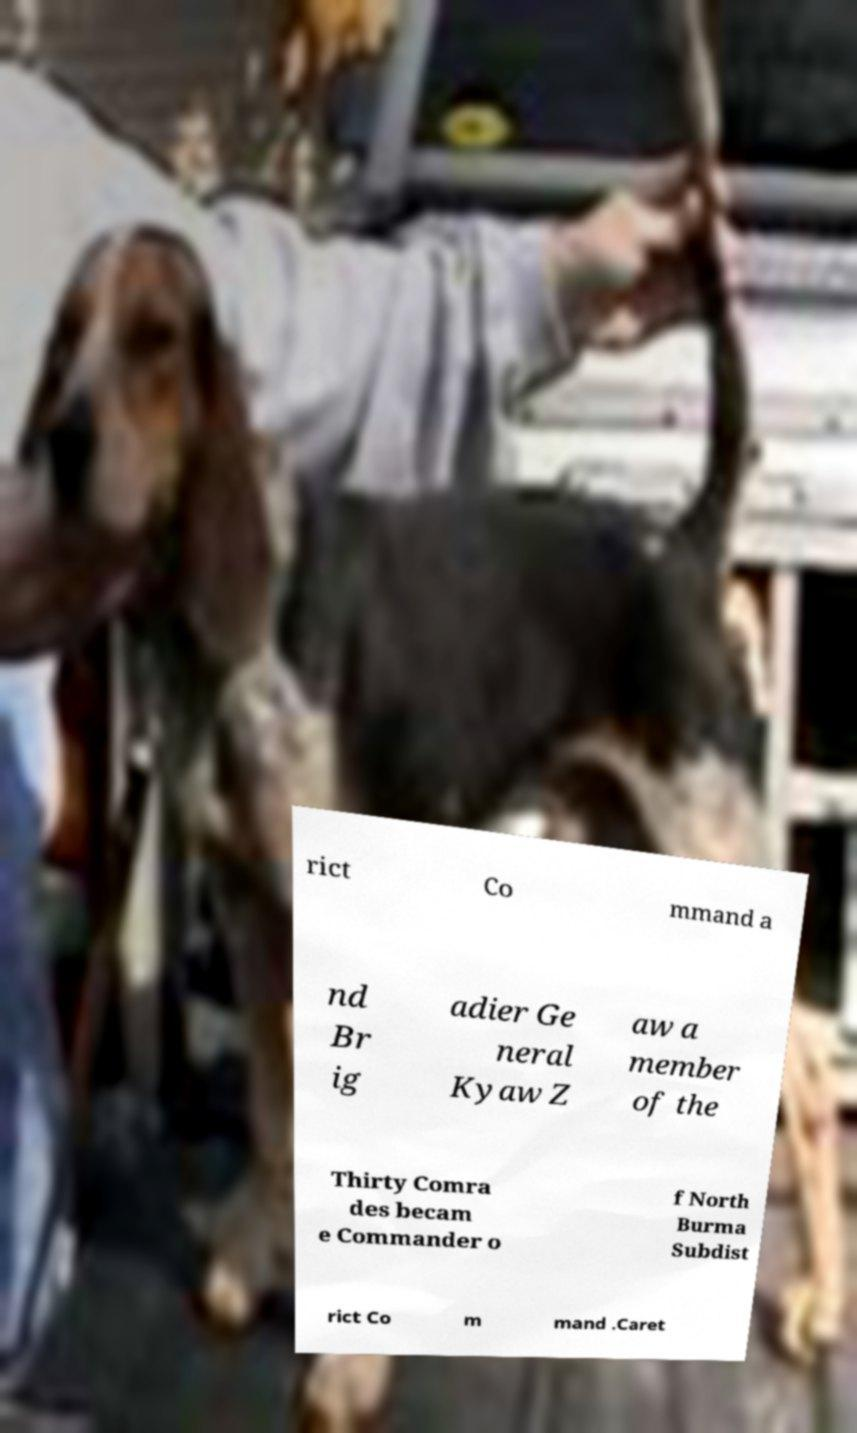Can you accurately transcribe the text from the provided image for me? rict Co mmand a nd Br ig adier Ge neral Kyaw Z aw a member of the Thirty Comra des becam e Commander o f North Burma Subdist rict Co m mand .Caret 